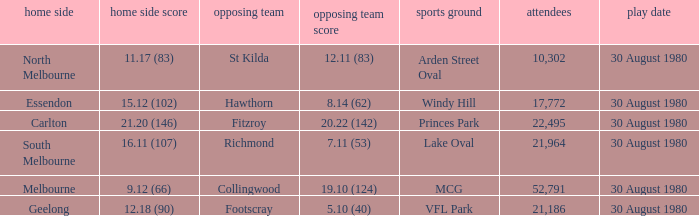What was the score for south melbourne at home? 16.11 (107). 